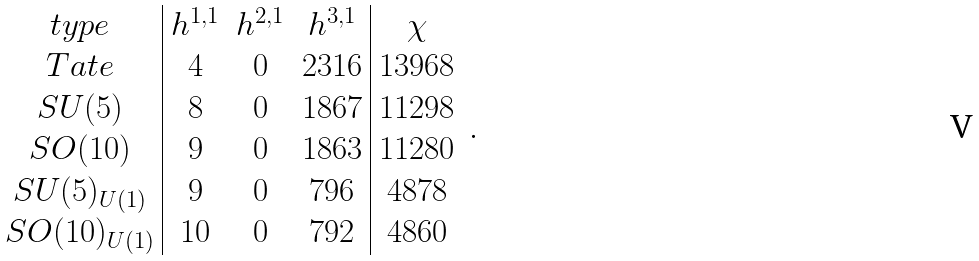Convert formula to latex. <formula><loc_0><loc_0><loc_500><loc_500>\begin{array} { c | c c c | c } t y p e & h ^ { 1 , 1 } & h ^ { 2 , 1 } & h ^ { 3 , 1 } & \chi \\ T a t e & 4 & 0 & 2 3 1 6 & 1 3 9 6 8 \\ S U ( 5 ) & 8 & 0 & 1 8 6 7 & 1 1 2 9 8 \\ S O ( 1 0 ) & 9 & 0 & 1 8 6 3 & 1 1 2 8 0 \\ S U ( 5 ) _ { U ( 1 ) } & 9 & 0 & 7 9 6 & 4 8 7 8 \\ S O ( 1 0 ) _ { U ( 1 ) } & 1 0 & 0 & 7 9 2 & 4 8 6 0 \end{array} \, .</formula> 